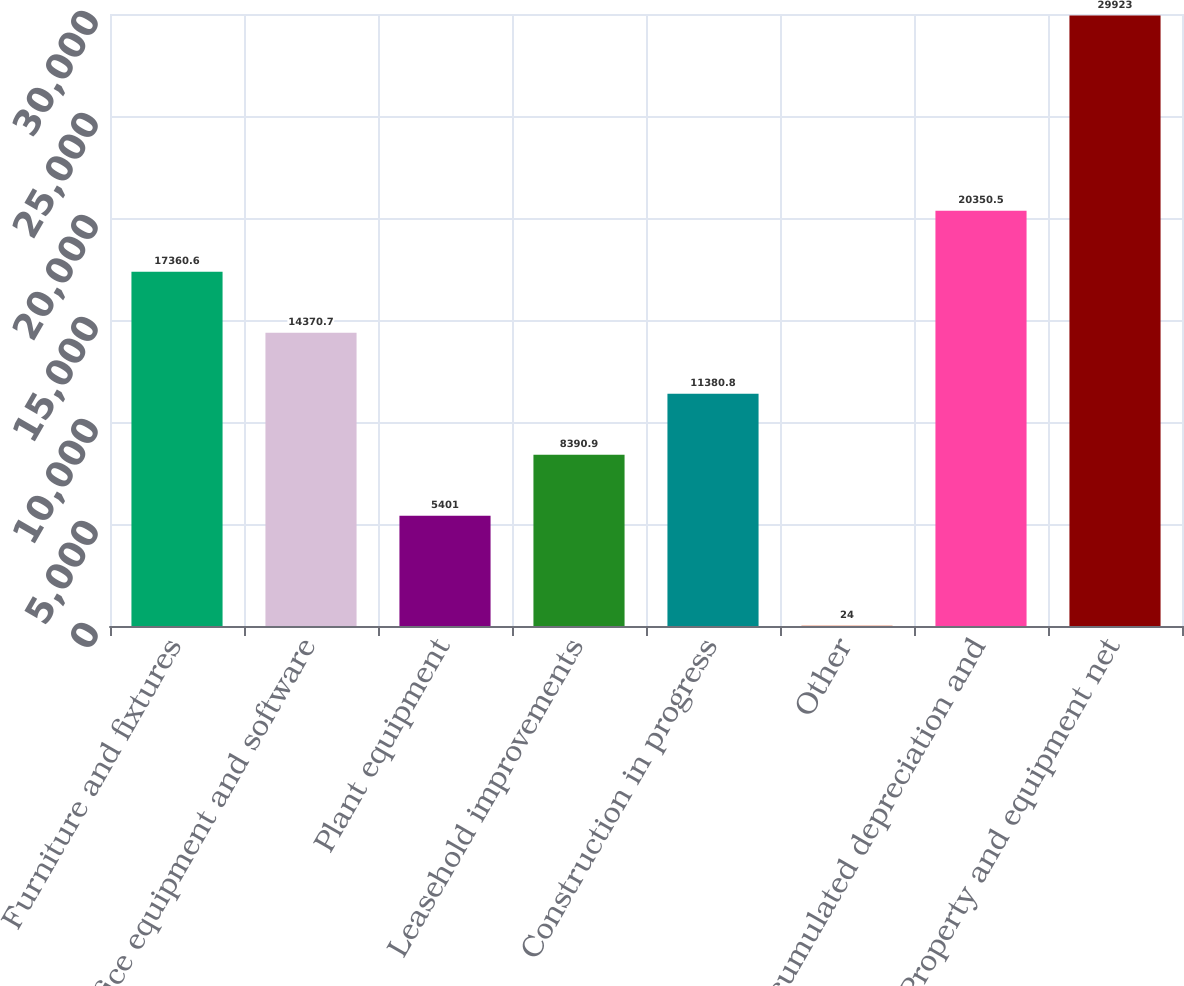<chart> <loc_0><loc_0><loc_500><loc_500><bar_chart><fcel>Furniture and fixtures<fcel>Office equipment and software<fcel>Plant equipment<fcel>Leasehold improvements<fcel>Construction in progress<fcel>Other<fcel>Accumulated depreciation and<fcel>Property and equipment net<nl><fcel>17360.6<fcel>14370.7<fcel>5401<fcel>8390.9<fcel>11380.8<fcel>24<fcel>20350.5<fcel>29923<nl></chart> 